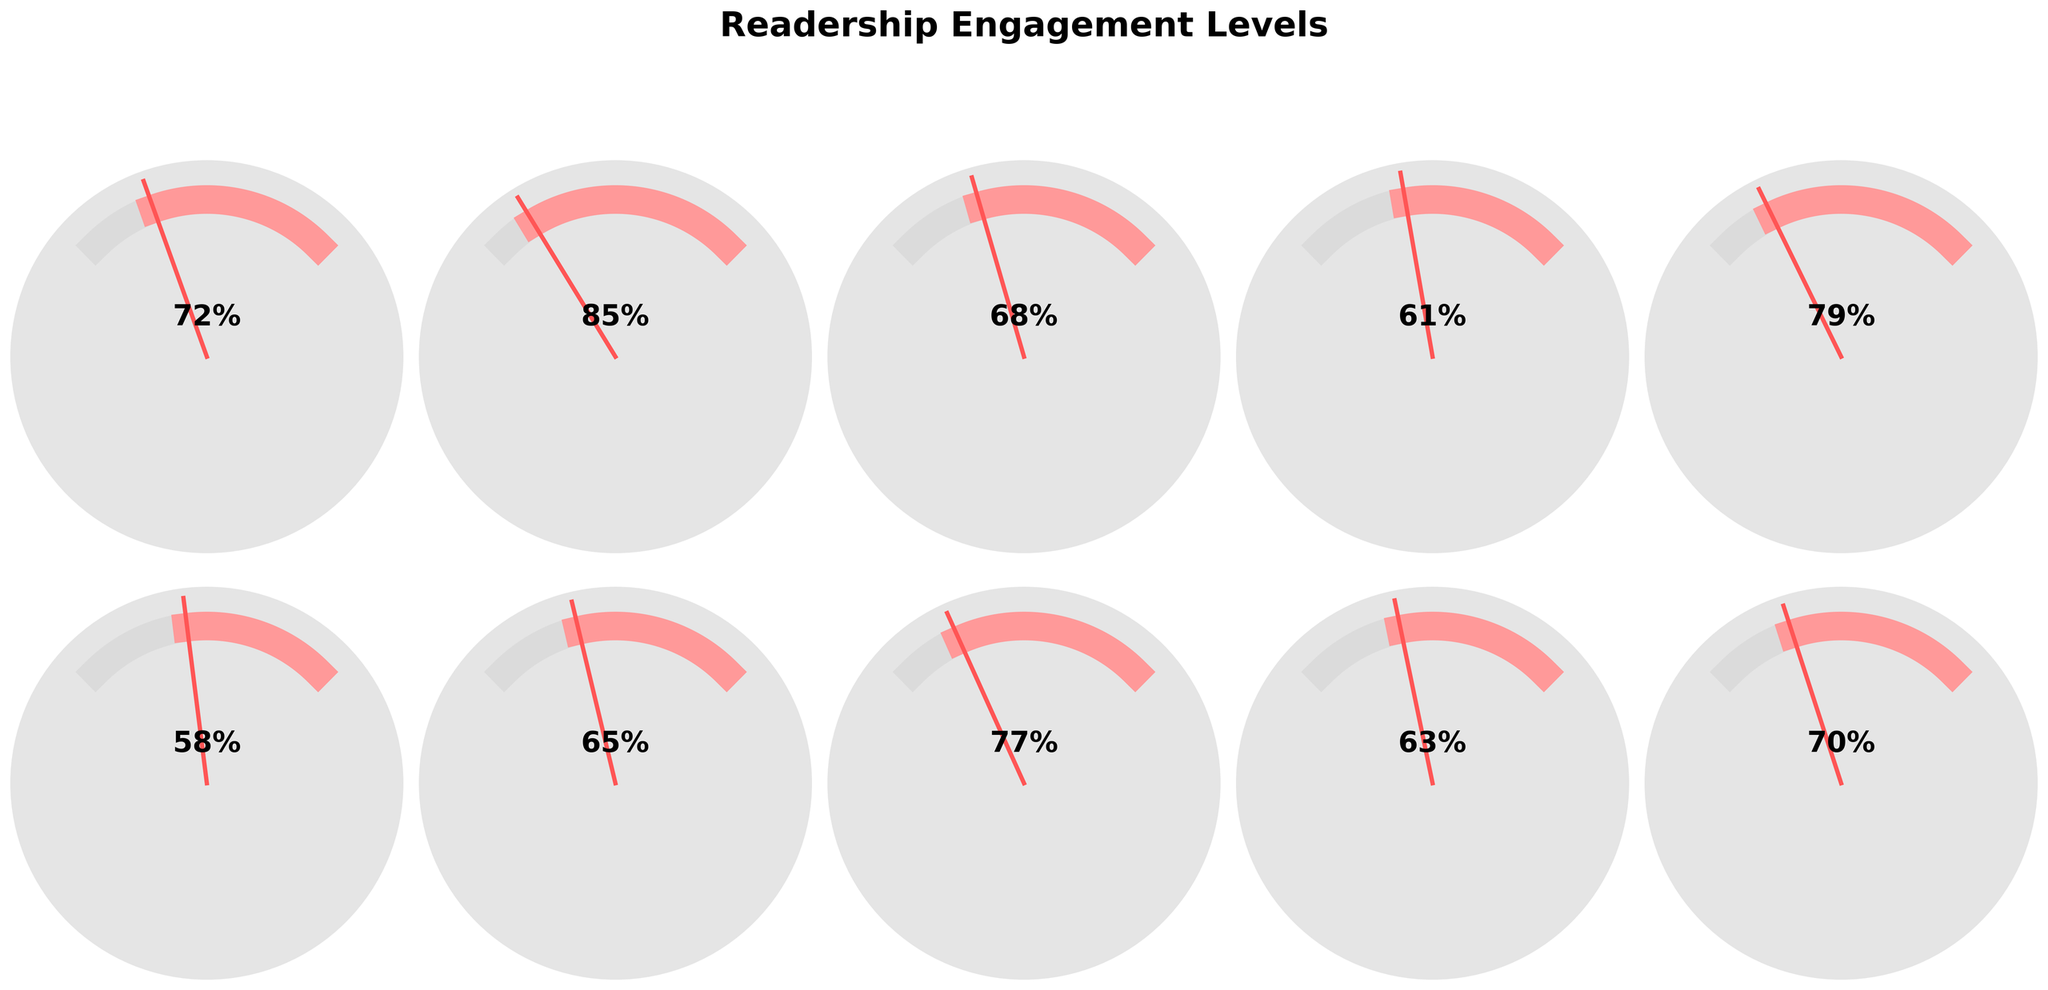Which content format has the highest engagement level? By examining the gauge chart, the highest value needle points to "Video Content," showing an engagement level of 85.
Answer: Video Content Which content format has the lowest engagement level? The gauge showing the lowest engagement level points to "Photo Essays," with an engagement level of 58.
Answer: Photo Essays What is the engagement level for Long-form Articles? The gauge for "Long-form Articles" shows a needle pointing to 72%.
Answer: 72% Which content format has an engagement level close to 70%? Both "Long-form Articles" and "Webinars" have engagement levels close to 70%, with "Webinars" at exactly 70%.
Answer: Webinars What is the difference in engagement levels between Infographics and Social Media Posts? Infographics have an engagement level of 68%, and Social Media Posts have 77%. The difference is 77% - 68% = 9%.
Answer: 9% Which content format with an engagement level over 80%? Only "Video Content" has an engagement level over 80%, with an engagement level of 85%.
Answer: Video Content What is the average engagement level of Infographics, Podcasts, and Email Newsletters? The engagement levels are Infographics 68%, Podcasts 61%, and Email Newsletters 63%. The average is (68 + 61 + 63)/3 = 64%.
Answer: 64% Are there any content formats with similar engagement levels? "Long-form Articles" and "Webinars" both have engagement levels very close to 70%, with 72% and 70%, respectively.
Answer: Yes (Long-form Articles and Webinars) Which content format's engagement level is higher: Short-form Blog Posts or Interactive Quizzes? Short-form Blog Posts have an engagement level of 65% while Interactive Quizzes have 79%. So, Interactive Quizzes have a higher engagement level.
Answer: Interactive Quizzes Do all content formats have an engagement level above 60%? By examining each gauge, we can see "Photo Essays" has an engagement level of 58%, below 60%. Hence, not all content formats have an engagement level above 60%.
Answer: No 